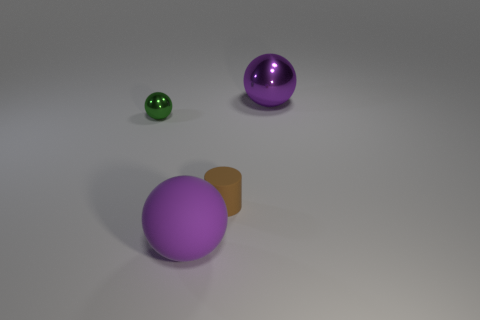Add 3 big blue matte cubes. How many objects exist? 7 Subtract all small metal spheres. How many spheres are left? 2 Subtract 2 balls. How many balls are left? 1 Subtract all spheres. How many objects are left? 1 Subtract all green spheres. How many spheres are left? 2 Subtract all yellow balls. Subtract all green cubes. How many balls are left? 3 Add 1 green spheres. How many green spheres exist? 2 Subtract 0 purple cubes. How many objects are left? 4 Subtract all gray cylinders. How many purple spheres are left? 2 Subtract all big shiny balls. Subtract all brown cylinders. How many objects are left? 2 